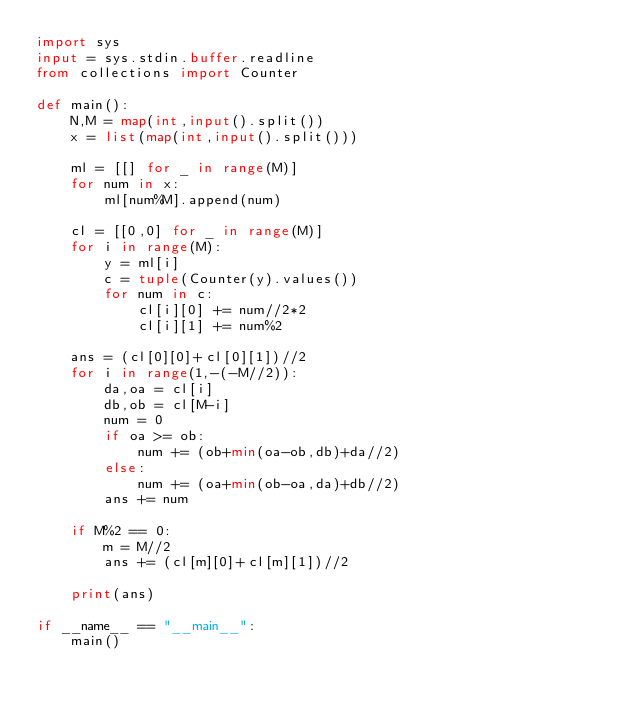Convert code to text. <code><loc_0><loc_0><loc_500><loc_500><_Python_>import sys
input = sys.stdin.buffer.readline
from collections import Counter

def main():
    N,M = map(int,input().split())
    x = list(map(int,input().split()))
    
    ml = [[] for _ in range(M)]
    for num in x:
        ml[num%M].append(num)

    cl = [[0,0] for _ in range(M)]
    for i in range(M):
        y = ml[i]
        c = tuple(Counter(y).values())
        for num in c:
            cl[i][0] += num//2*2
            cl[i][1] += num%2

    ans = (cl[0][0]+cl[0][1])//2
    for i in range(1,-(-M//2)):
        da,oa = cl[i]
        db,ob = cl[M-i]
        num = 0
        if oa >= ob:
            num += (ob+min(oa-ob,db)+da//2)
        else:
            num += (oa+min(ob-oa,da)+db//2)
        ans += num
    
    if M%2 == 0:
        m = M//2
        ans += (cl[m][0]+cl[m][1])//2
        
    print(ans)

if __name__ == "__main__":
    main()</code> 